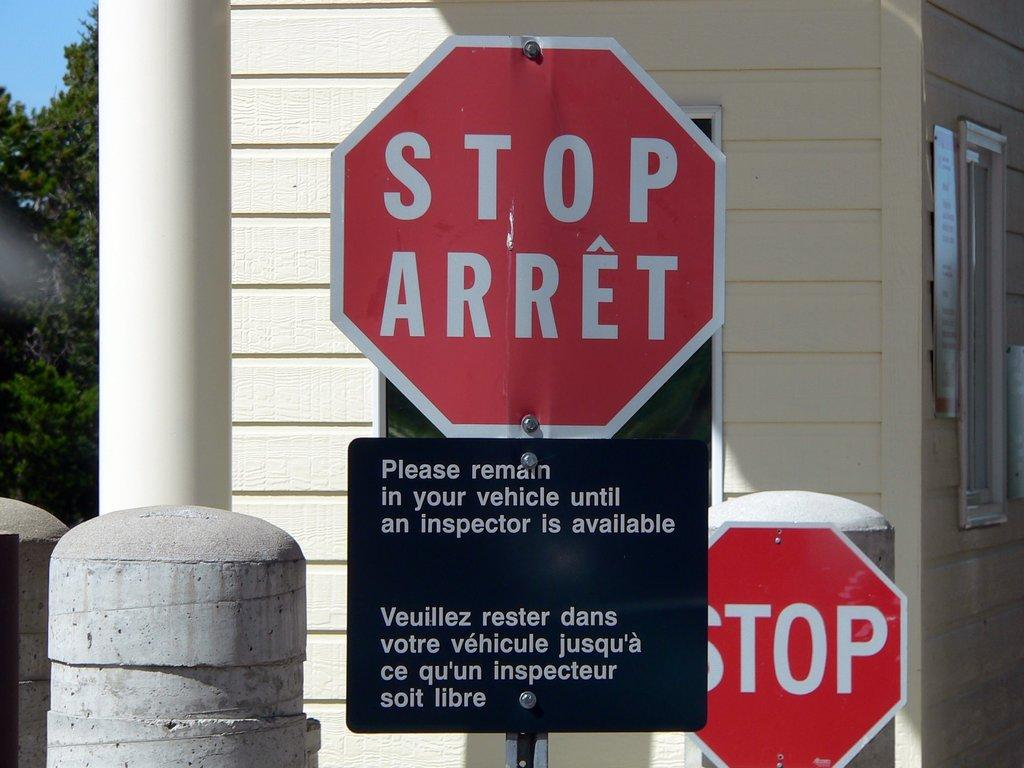<image>
Provide a brief description of the given image. A stop sign at a checkpoint informing the travellers to remain in their vehicles until an inspector arrives. 